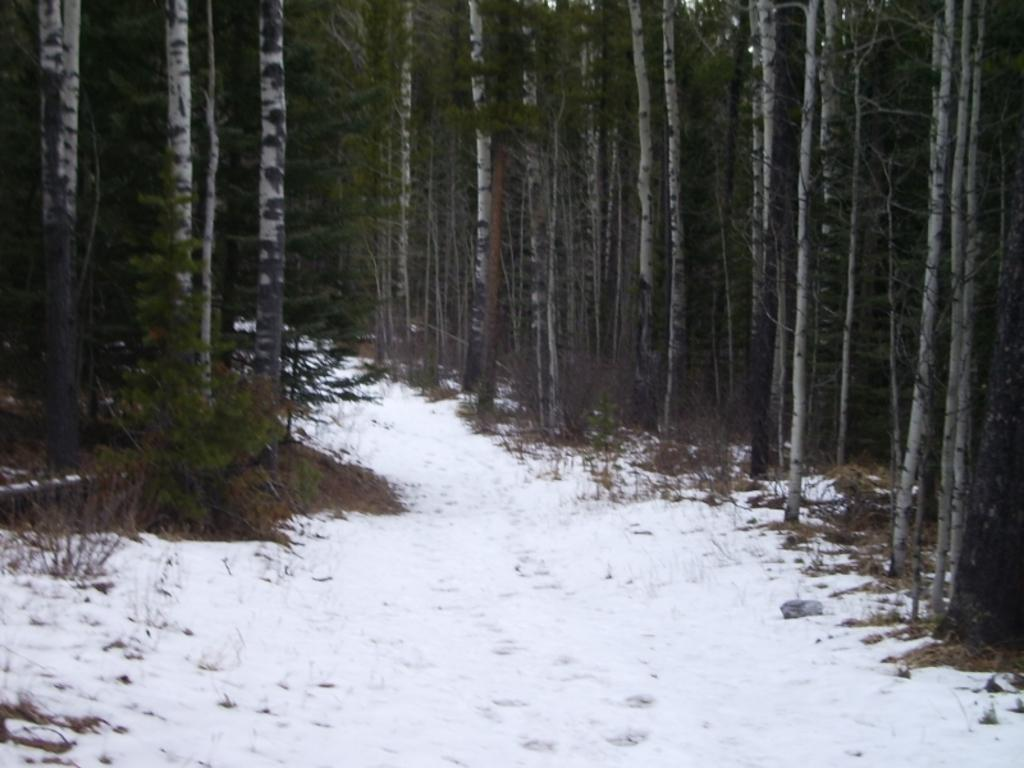What is the condition of the land in the image? The land in the image is covered with snow. What can be seen in the background of the image? There are trees in the background of the image. What type of dress is the jellyfish wearing in the image? There is no jellyfish or dress present in the image; it features snow-covered land and trees in the background. 